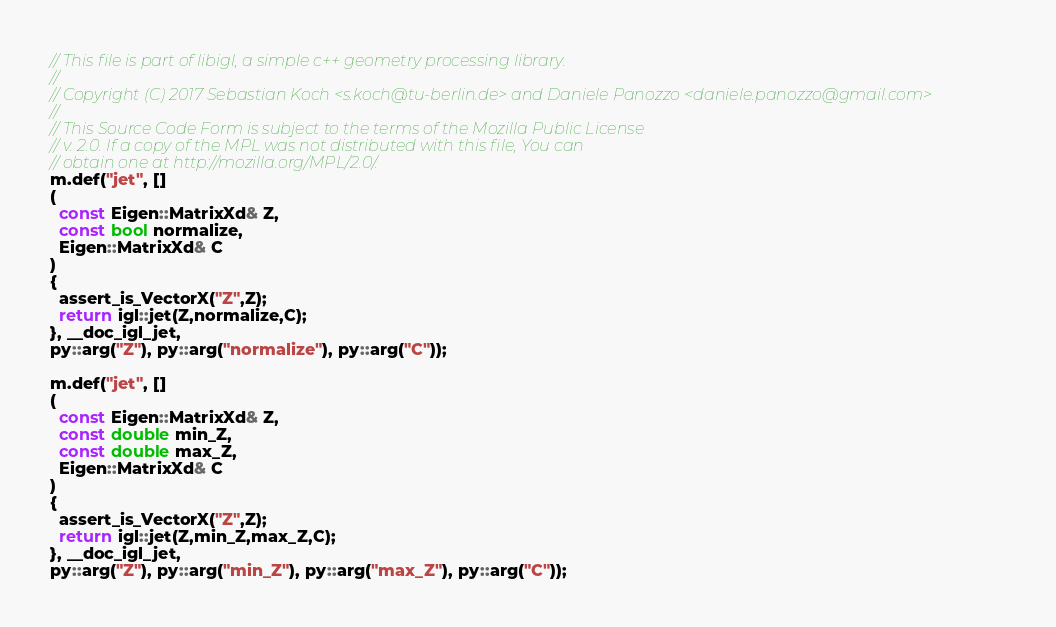Convert code to text. <code><loc_0><loc_0><loc_500><loc_500><_C++_>// This file is part of libigl, a simple c++ geometry processing library.
//
// Copyright (C) 2017 Sebastian Koch <s.koch@tu-berlin.de> and Daniele Panozzo <daniele.panozzo@gmail.com>
//
// This Source Code Form is subject to the terms of the Mozilla Public License
// v. 2.0. If a copy of the MPL was not distributed with this file, You can
// obtain one at http://mozilla.org/MPL/2.0/.
m.def("jet", []
(
  const Eigen::MatrixXd& Z,
  const bool normalize,
  Eigen::MatrixXd& C
)
{
  assert_is_VectorX("Z",Z);
  return igl::jet(Z,normalize,C);
}, __doc_igl_jet,
py::arg("Z"), py::arg("normalize"), py::arg("C"));

m.def("jet", []
(
  const Eigen::MatrixXd& Z,
  const double min_Z,
  const double max_Z,
  Eigen::MatrixXd& C
)
{
  assert_is_VectorX("Z",Z);
  return igl::jet(Z,min_Z,max_Z,C);
}, __doc_igl_jet,
py::arg("Z"), py::arg("min_Z"), py::arg("max_Z"), py::arg("C"));
</code> 